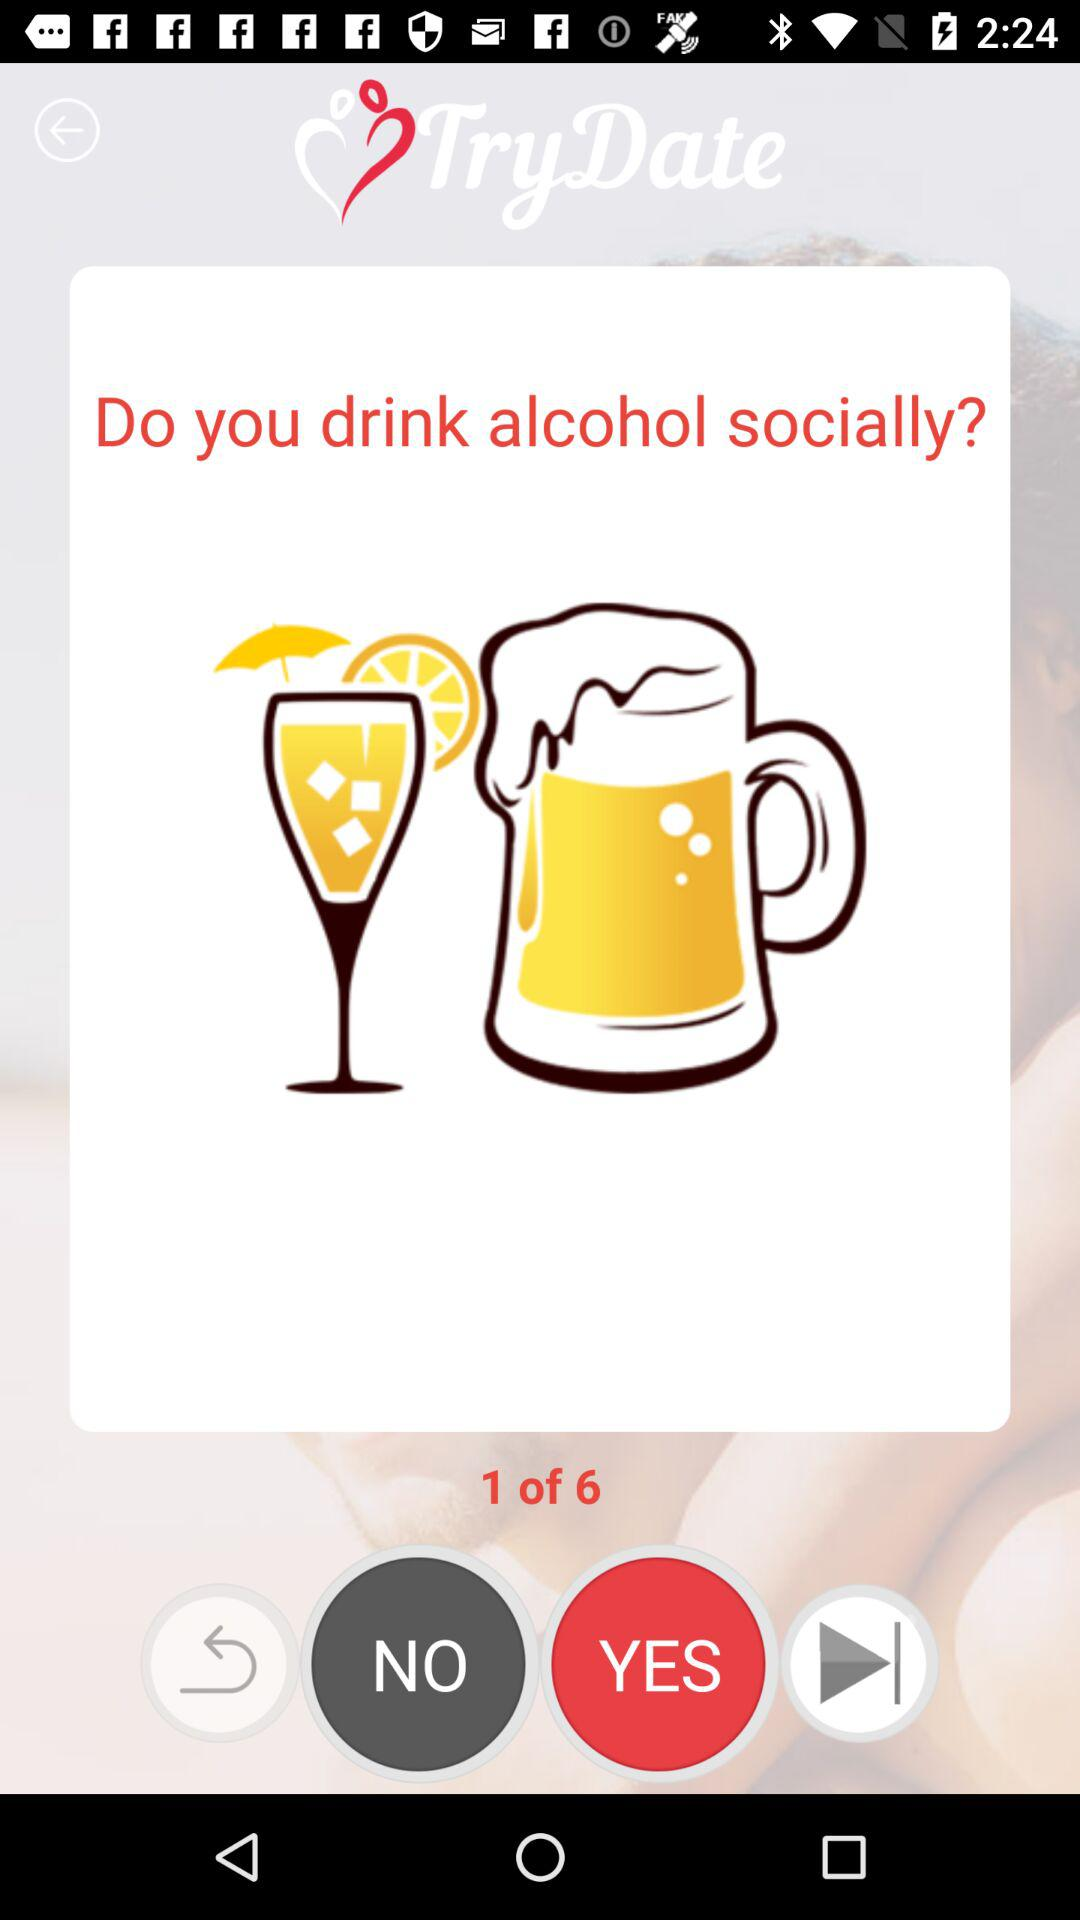How many questions in total are there? There are 6 questions in total. 